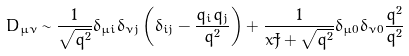<formula> <loc_0><loc_0><loc_500><loc_500>D _ { \mu \nu } \sim \frac { 1 } { \sqrt { q ^ { 2 } } } \delta _ { \mu i } \delta _ { \nu j } \left ( \delta _ { i j } - \frac { q _ { i } q _ { j } } { { q } ^ { 2 } } \right ) + \frac { 1 } { x \tilde { J } + \sqrt { q ^ { 2 } } } \delta _ { \mu 0 } \delta _ { \nu 0 } \frac { q ^ { 2 } } { { q } ^ { 2 } }</formula> 